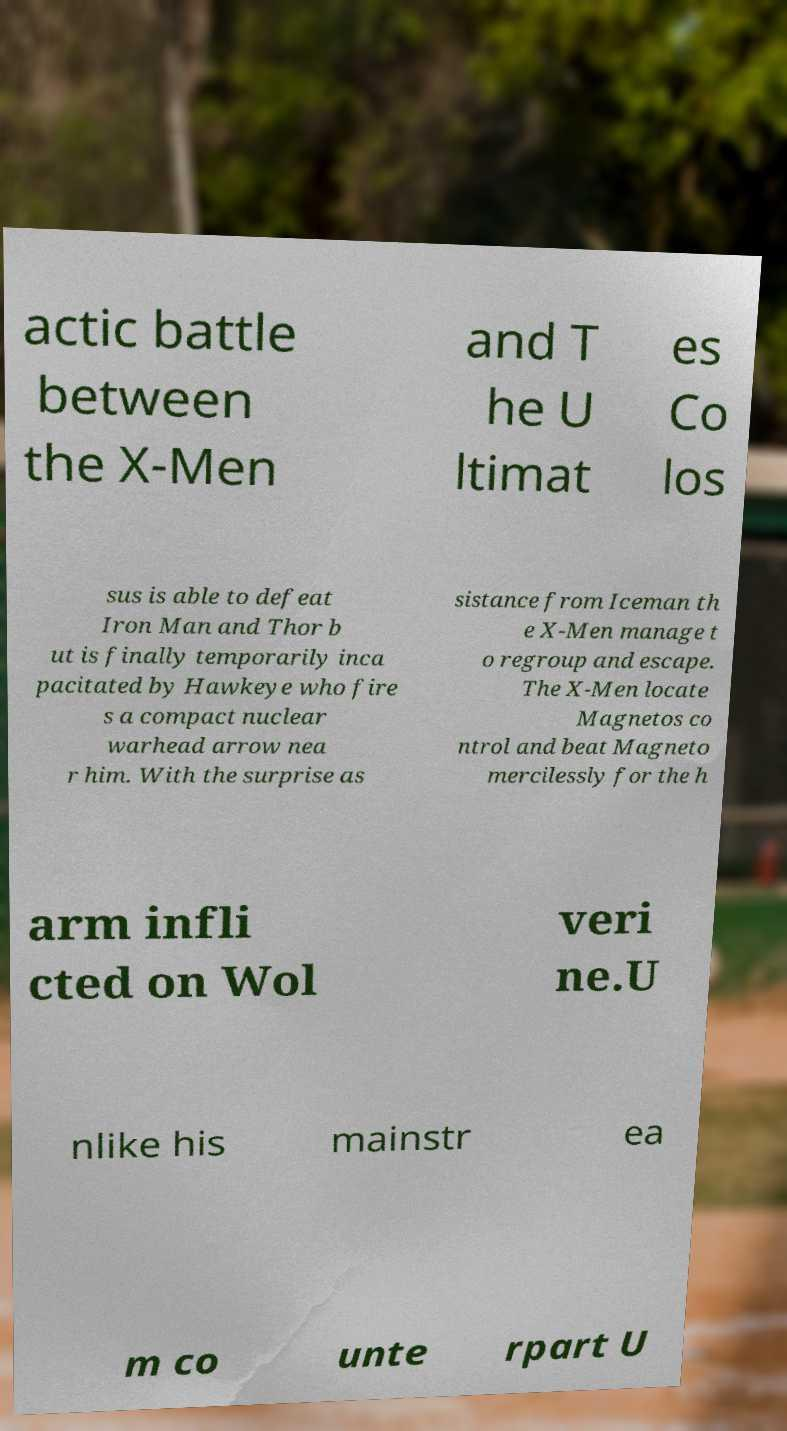What messages or text are displayed in this image? I need them in a readable, typed format. actic battle between the X-Men and T he U ltimat es Co los sus is able to defeat Iron Man and Thor b ut is finally temporarily inca pacitated by Hawkeye who fire s a compact nuclear warhead arrow nea r him. With the surprise as sistance from Iceman th e X-Men manage t o regroup and escape. The X-Men locate Magnetos co ntrol and beat Magneto mercilessly for the h arm infli cted on Wol veri ne.U nlike his mainstr ea m co unte rpart U 